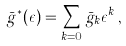<formula> <loc_0><loc_0><loc_500><loc_500>\bar { g } ^ { * } ( \epsilon ) = \sum _ { k = 0 } \bar { g } _ { k } \epsilon ^ { k } \, ,</formula> 